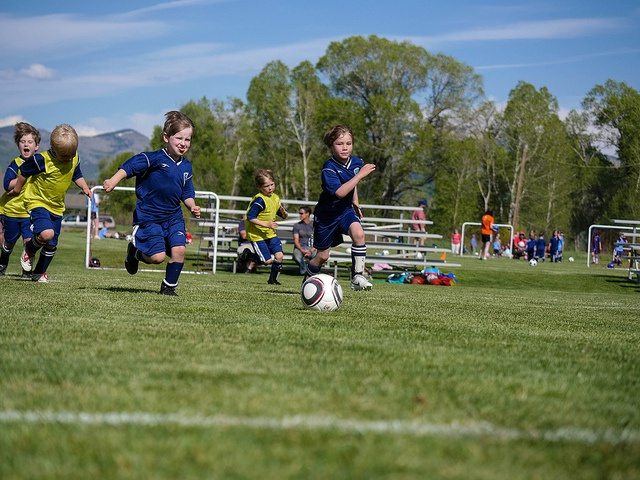Describe the objects in this image and their specific colors. I can see people in gray, black, navy, darkblue, and lightpink tones, people in gray, black, olive, and navy tones, people in gray, black, navy, and lightpink tones, people in gray, black, navy, and olive tones, and people in gray, black, navy, and olive tones in this image. 